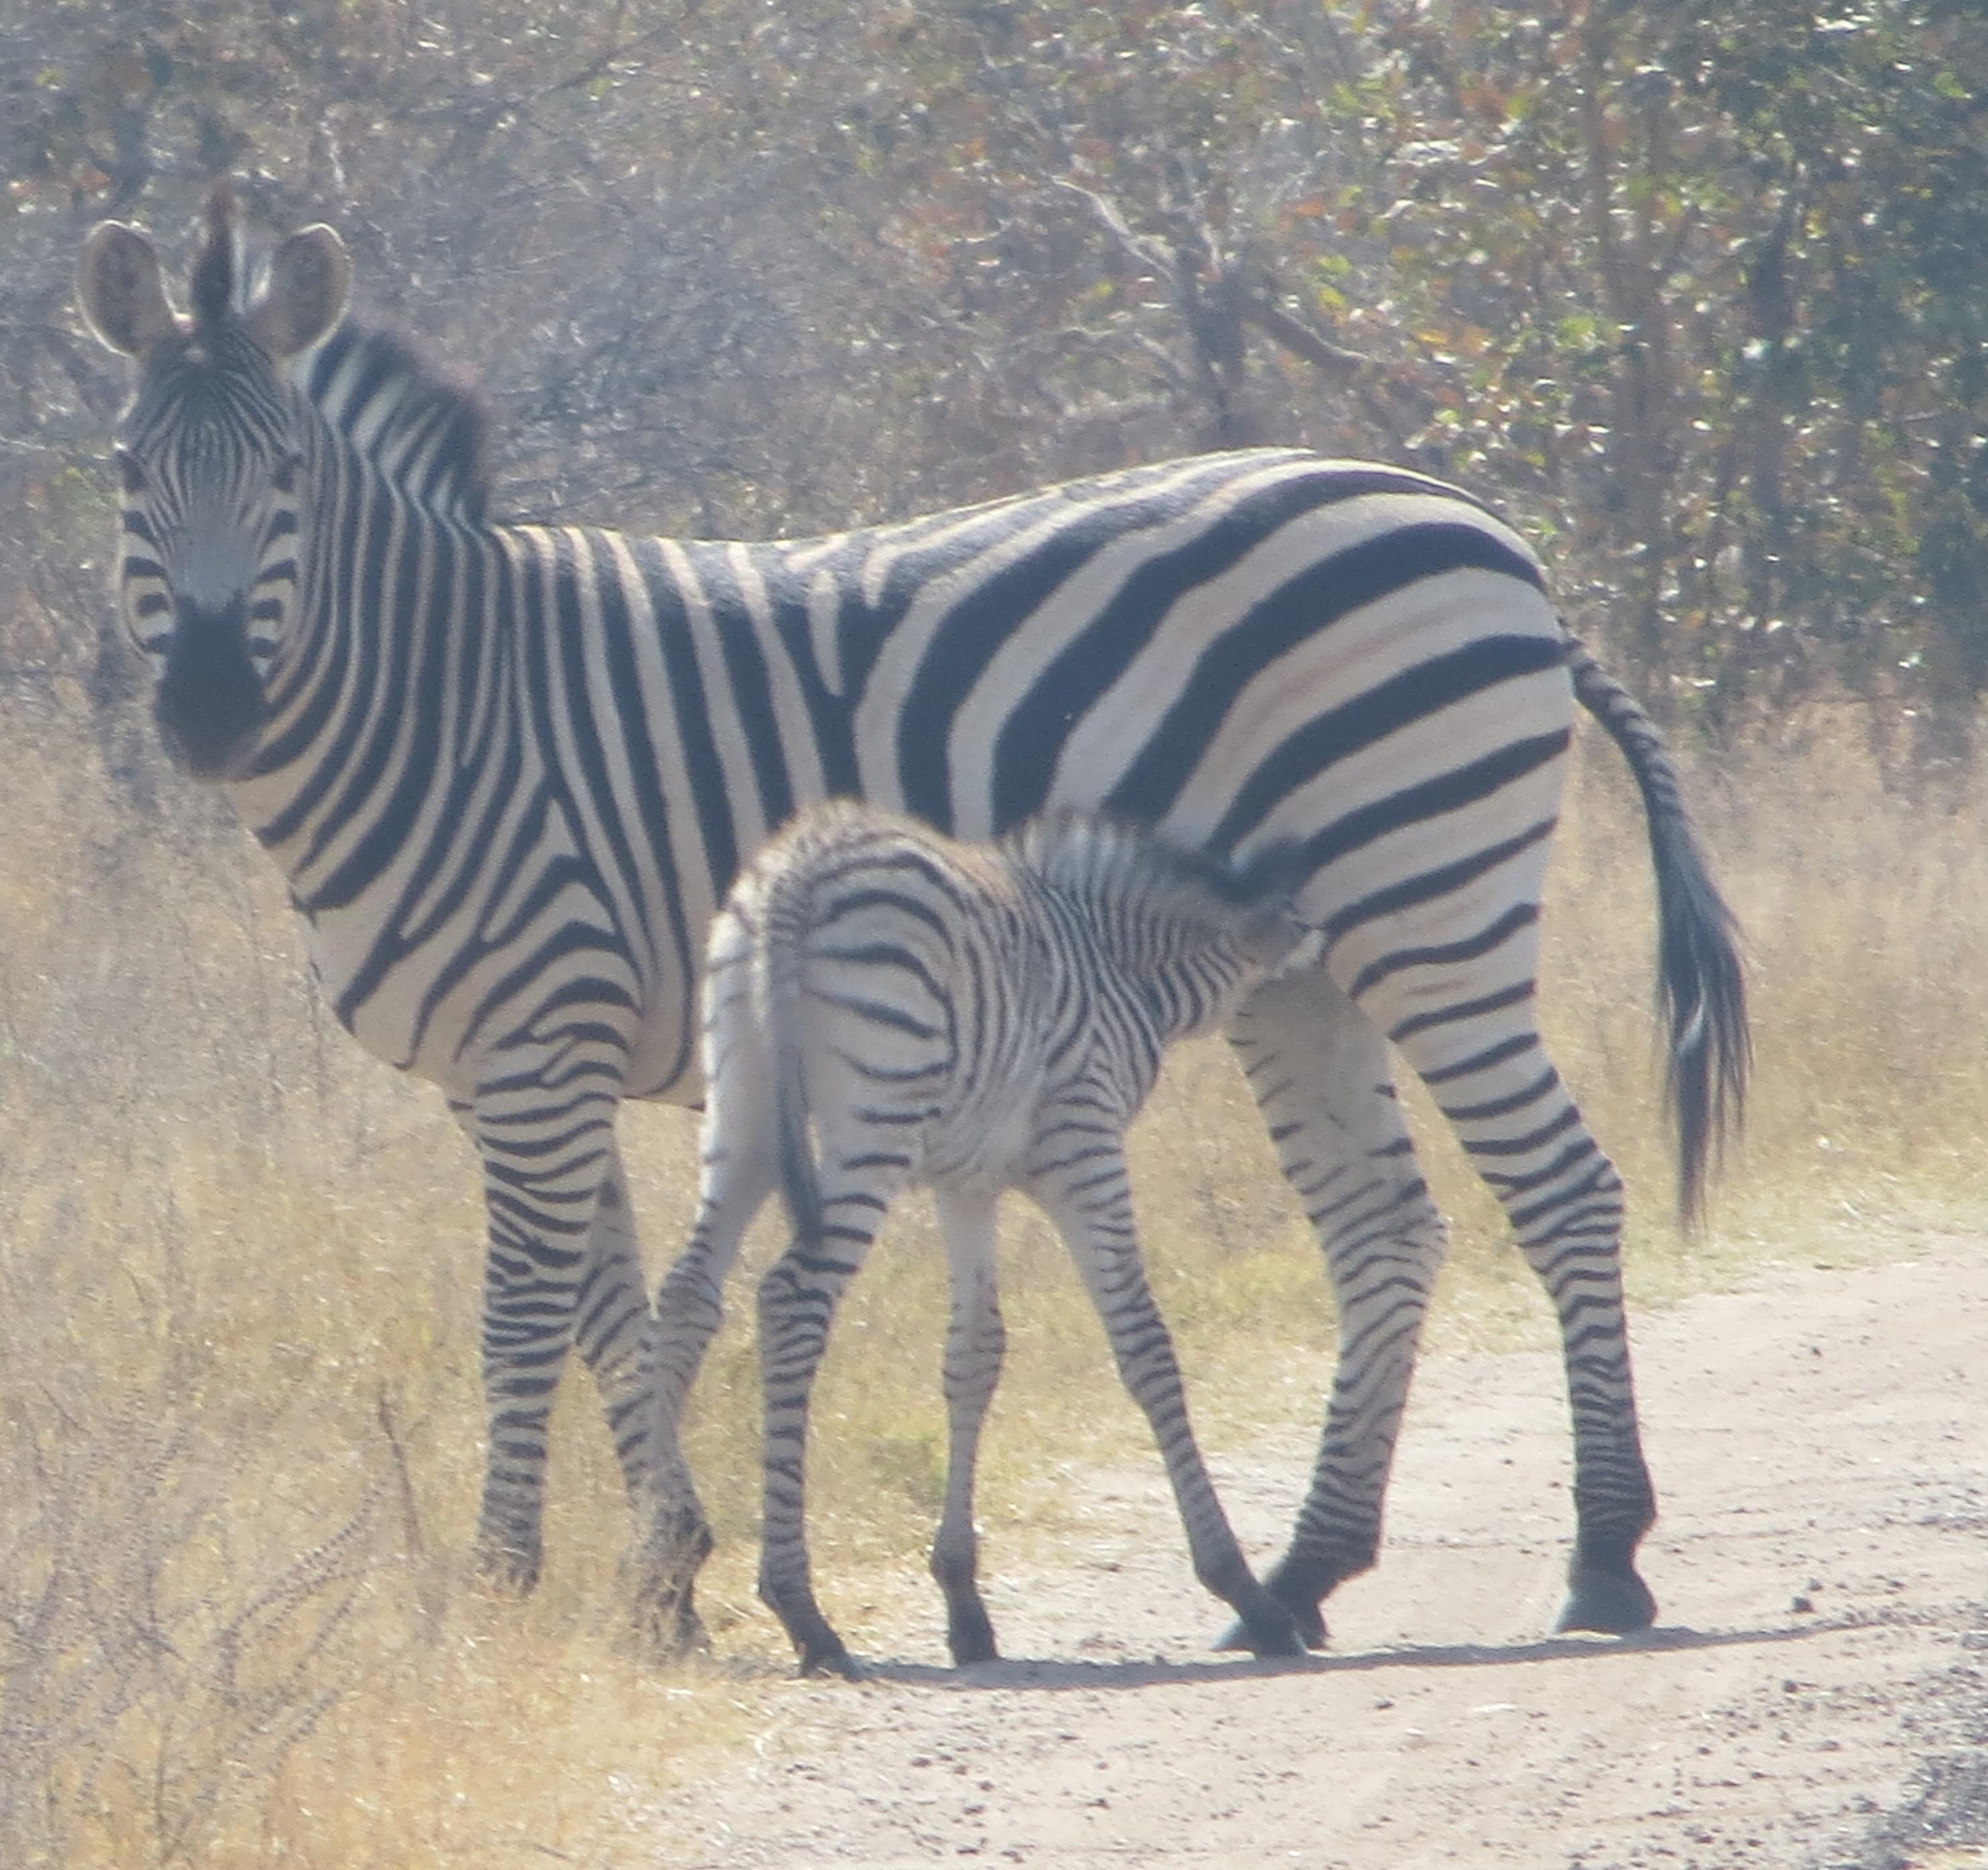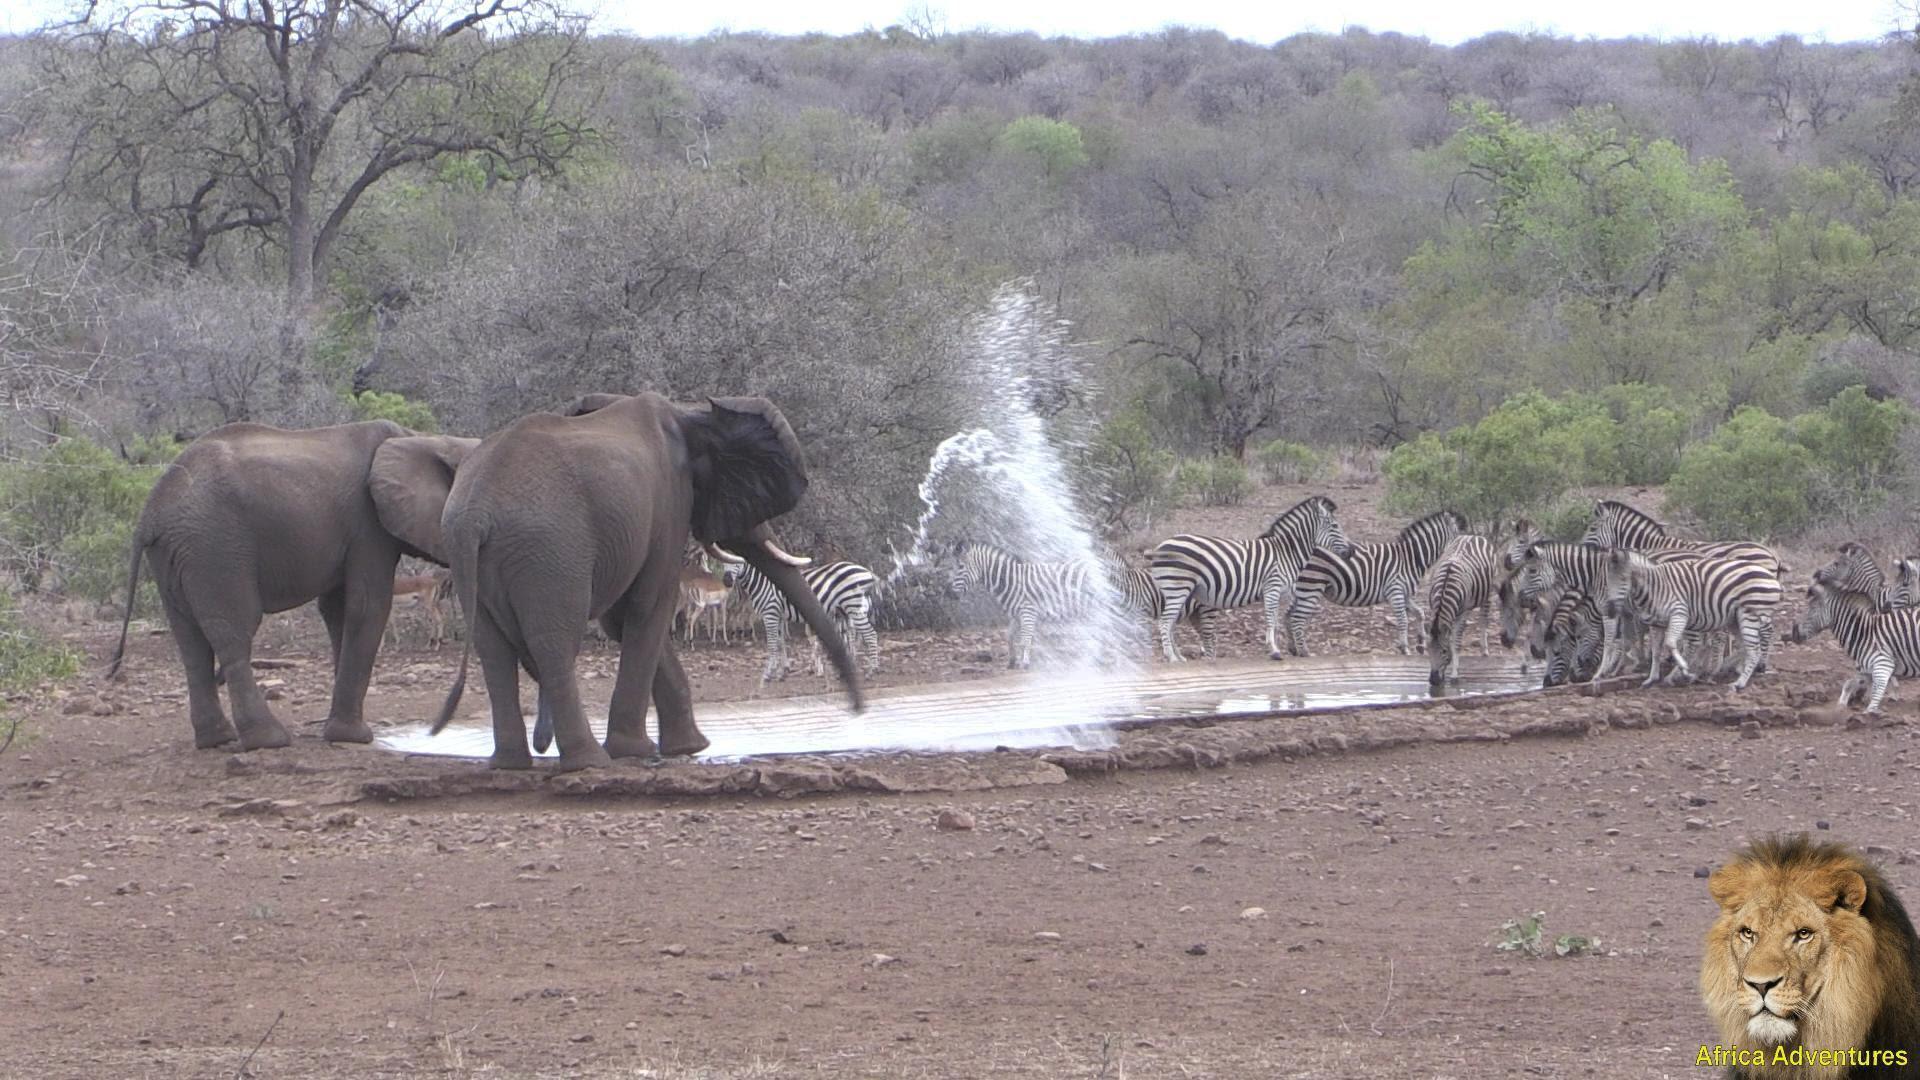The first image is the image on the left, the second image is the image on the right. Given the left and right images, does the statement "The combined images include zebra at a watering hole and a rear-facing elephant near a standing zebra." hold true? Answer yes or no. Yes. The first image is the image on the left, the second image is the image on the right. Examine the images to the left and right. Is the description "Zebras are running." accurate? Answer yes or no. No. 